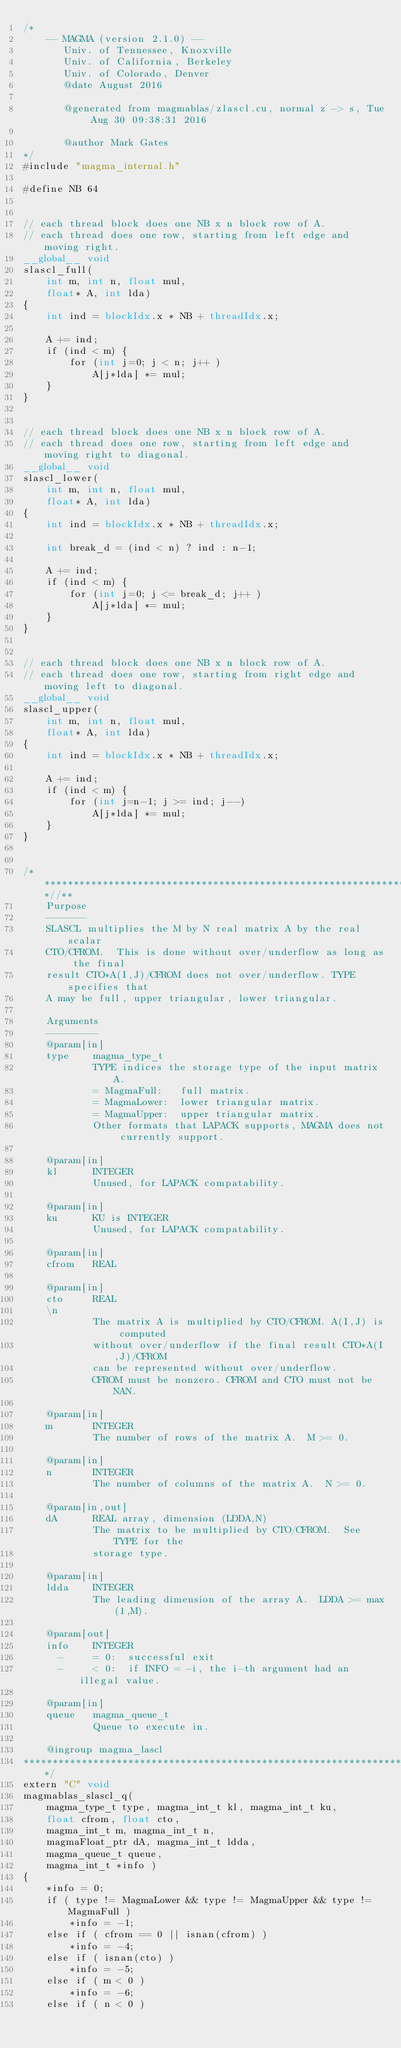<code> <loc_0><loc_0><loc_500><loc_500><_Cuda_>/*
    -- MAGMA (version 2.1.0) --
       Univ. of Tennessee, Knoxville
       Univ. of California, Berkeley
       Univ. of Colorado, Denver
       @date August 2016

       @generated from magmablas/zlascl.cu, normal z -> s, Tue Aug 30 09:38:31 2016

       @author Mark Gates
*/
#include "magma_internal.h"

#define NB 64


// each thread block does one NB x n block row of A.
// each thread does one row, starting from left edge and moving right.
__global__ void
slascl_full(
    int m, int n, float mul,
    float* A, int lda)
{
    int ind = blockIdx.x * NB + threadIdx.x;

    A += ind;
    if (ind < m) {
        for (int j=0; j < n; j++ )
            A[j*lda] *= mul;
    }
}


// each thread block does one NB x n block row of A.
// each thread does one row, starting from left edge and moving right to diagonal.
__global__ void
slascl_lower(
    int m, int n, float mul,
    float* A, int lda)
{
    int ind = blockIdx.x * NB + threadIdx.x;

    int break_d = (ind < n) ? ind : n-1;

    A += ind;
    if (ind < m) {
        for (int j=0; j <= break_d; j++ )
            A[j*lda] *= mul;
    }
}


// each thread block does one NB x n block row of A.
// each thread does one row, starting from right edge and moving left to diagonal.
__global__ void
slascl_upper(
    int m, int n, float mul,
    float* A, int lda)
{
    int ind = blockIdx.x * NB + threadIdx.x;

    A += ind;
    if (ind < m) {
        for (int j=n-1; j >= ind; j--)
            A[j*lda] *= mul;
    }
}


/***************************************************************************//**
    Purpose
    -------
    SLASCL multiplies the M by N real matrix A by the real scalar
    CTO/CFROM.  This is done without over/underflow as long as the final
    result CTO*A(I,J)/CFROM does not over/underflow. TYPE specifies that
    A may be full, upper triangular, lower triangular.

    Arguments
    ---------
    @param[in]
    type    magma_type_t
            TYPE indices the storage type of the input matrix A.
            = MagmaFull:   full matrix.
            = MagmaLower:  lower triangular matrix.
            = MagmaUpper:  upper triangular matrix.
            Other formats that LAPACK supports, MAGMA does not currently support.

    @param[in]
    kl      INTEGER
            Unused, for LAPACK compatability.

    @param[in]
    ku      KU is INTEGER
            Unused, for LAPACK compatability.

    @param[in]
    cfrom   REAL

    @param[in]
    cto     REAL
    \n
            The matrix A is multiplied by CTO/CFROM. A(I,J) is computed
            without over/underflow if the final result CTO*A(I,J)/CFROM
            can be represented without over/underflow.
            CFROM must be nonzero. CFROM and CTO must not be NAN.

    @param[in]
    m       INTEGER
            The number of rows of the matrix A.  M >= 0.

    @param[in]
    n       INTEGER
            The number of columns of the matrix A.  N >= 0.

    @param[in,out]
    dA      REAL array, dimension (LDDA,N)
            The matrix to be multiplied by CTO/CFROM.  See TYPE for the
            storage type.

    @param[in]
    ldda    INTEGER
            The leading dimension of the array A.  LDDA >= max(1,M).

    @param[out]
    info    INTEGER
      -     = 0:  successful exit
      -     < 0:  if INFO = -i, the i-th argument had an illegal value.
    
    @param[in]
    queue   magma_queue_t
            Queue to execute in.

    @ingroup magma_lascl
*******************************************************************************/
extern "C" void
magmablas_slascl_q(
    magma_type_t type, magma_int_t kl, magma_int_t ku,
    float cfrom, float cto,
    magma_int_t m, magma_int_t n,
    magmaFloat_ptr dA, magma_int_t ldda,
    magma_queue_t queue,
    magma_int_t *info )
{
    *info = 0;
    if ( type != MagmaLower && type != MagmaUpper && type != MagmaFull )
        *info = -1;
    else if ( cfrom == 0 || isnan(cfrom) )
        *info = -4;
    else if ( isnan(cto) )
        *info = -5;
    else if ( m < 0 )
        *info = -6;
    else if ( n < 0 )</code> 